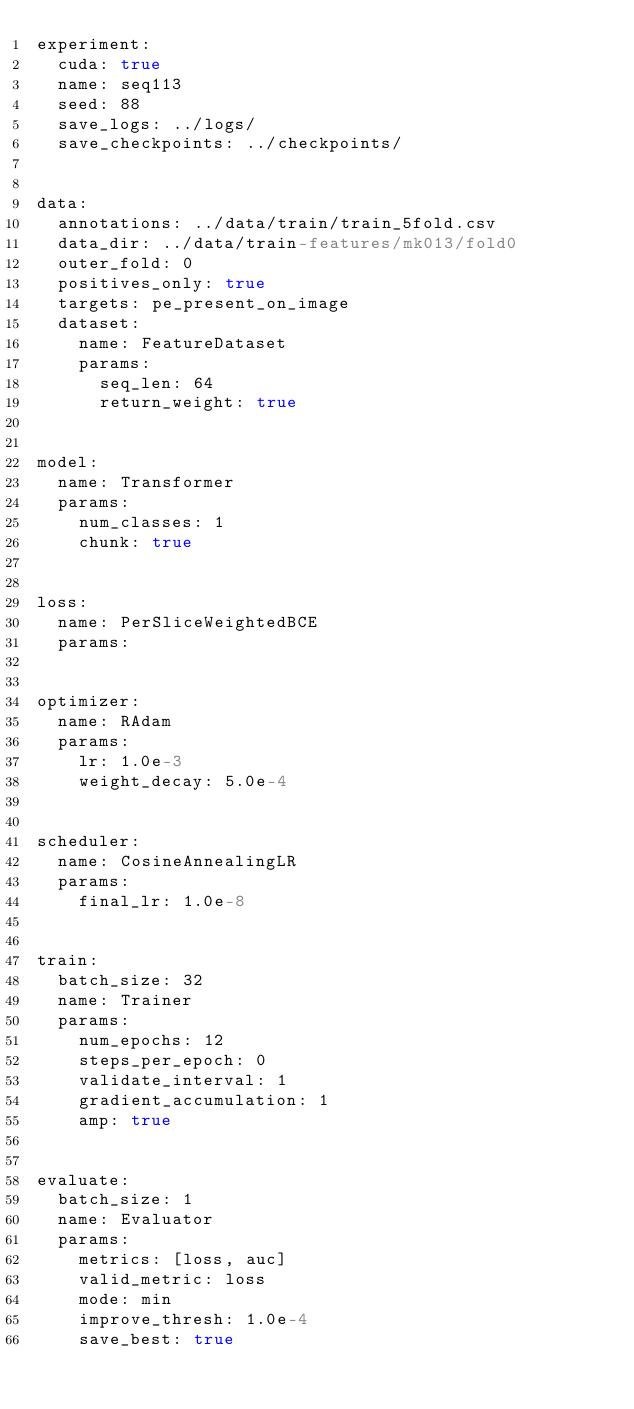<code> <loc_0><loc_0><loc_500><loc_500><_YAML_>experiment:
  cuda: true
  name: seq113
  seed: 88
  save_logs: ../logs/
  save_checkpoints: ../checkpoints/


data: 
  annotations: ../data/train/train_5fold.csv
  data_dir: ../data/train-features/mk013/fold0
  outer_fold: 0
  positives_only: true
  targets: pe_present_on_image
  dataset:
    name: FeatureDataset
    params:
      seq_len: 64
      return_weight: true


model:
  name: Transformer
  params:
    num_classes: 1
    chunk: true


loss:
  name: PerSliceWeightedBCE
  params:


optimizer:
  name: RAdam
  params:
    lr: 1.0e-3
    weight_decay: 5.0e-4


scheduler: 
  name: CosineAnnealingLR
  params:
    final_lr: 1.0e-8


train:
  batch_size: 32
  name: Trainer
  params:
    num_epochs: 12
    steps_per_epoch: 0
    validate_interval: 1
    gradient_accumulation: 1
    amp: true


evaluate: 
  batch_size: 1
  name: Evaluator
  params:
    metrics: [loss, auc]
    valid_metric: loss
    mode: min
    improve_thresh: 1.0e-4
    save_best: true


</code> 